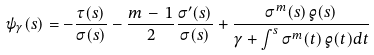Convert formula to latex. <formula><loc_0><loc_0><loc_500><loc_500>\psi _ { \gamma } ( s ) = - \frac { \tau ( s ) } { \sigma ( s ) } - \frac { m \, - \, 1 } { 2 } \frac { \sigma ^ { \prime } ( s ) } { \sigma ( s ) } + \frac { \sigma ^ { m } ( s ) \, \varrho ( s ) } { \gamma + \int ^ { s } \sigma ^ { m } ( t ) \, \varrho ( t ) d t }</formula> 